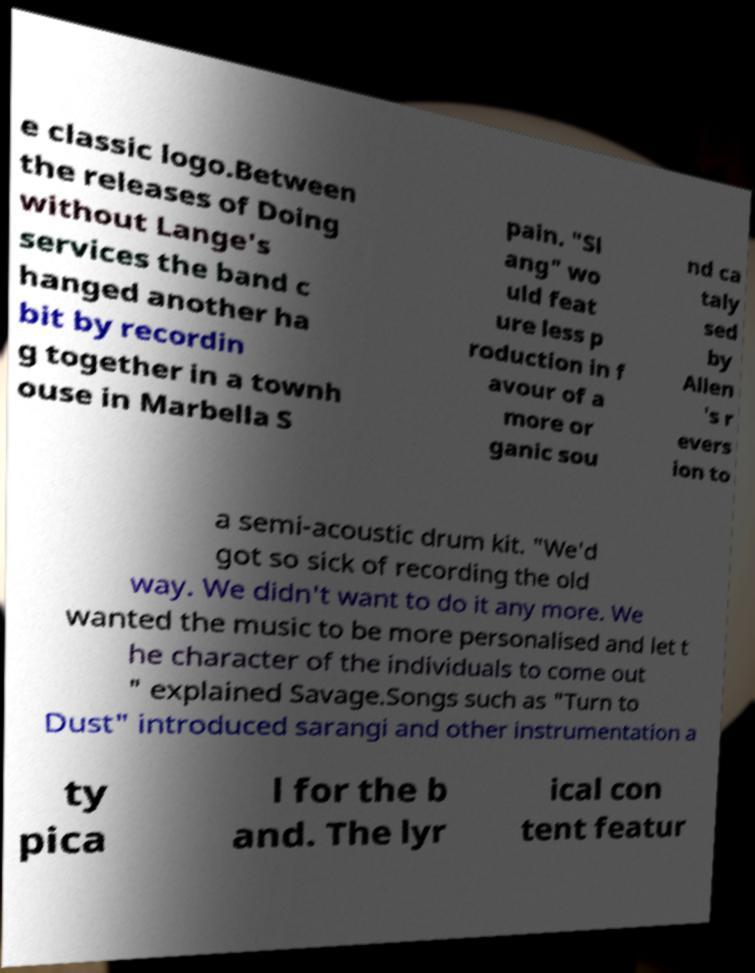There's text embedded in this image that I need extracted. Can you transcribe it verbatim? e classic logo.Between the releases of Doing without Lange's services the band c hanged another ha bit by recordin g together in a townh ouse in Marbella S pain. "Sl ang" wo uld feat ure less p roduction in f avour of a more or ganic sou nd ca taly sed by Allen 's r evers ion to a semi-acoustic drum kit. "We'd got so sick of recording the old way. We didn't want to do it any more. We wanted the music to be more personalised and let t he character of the individuals to come out " explained Savage.Songs such as "Turn to Dust" introduced sarangi and other instrumentation a ty pica l for the b and. The lyr ical con tent featur 